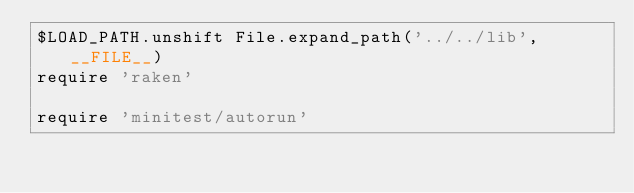<code> <loc_0><loc_0><loc_500><loc_500><_Ruby_>$LOAD_PATH.unshift File.expand_path('../../lib', __FILE__)
require 'raken'

require 'minitest/autorun'
</code> 